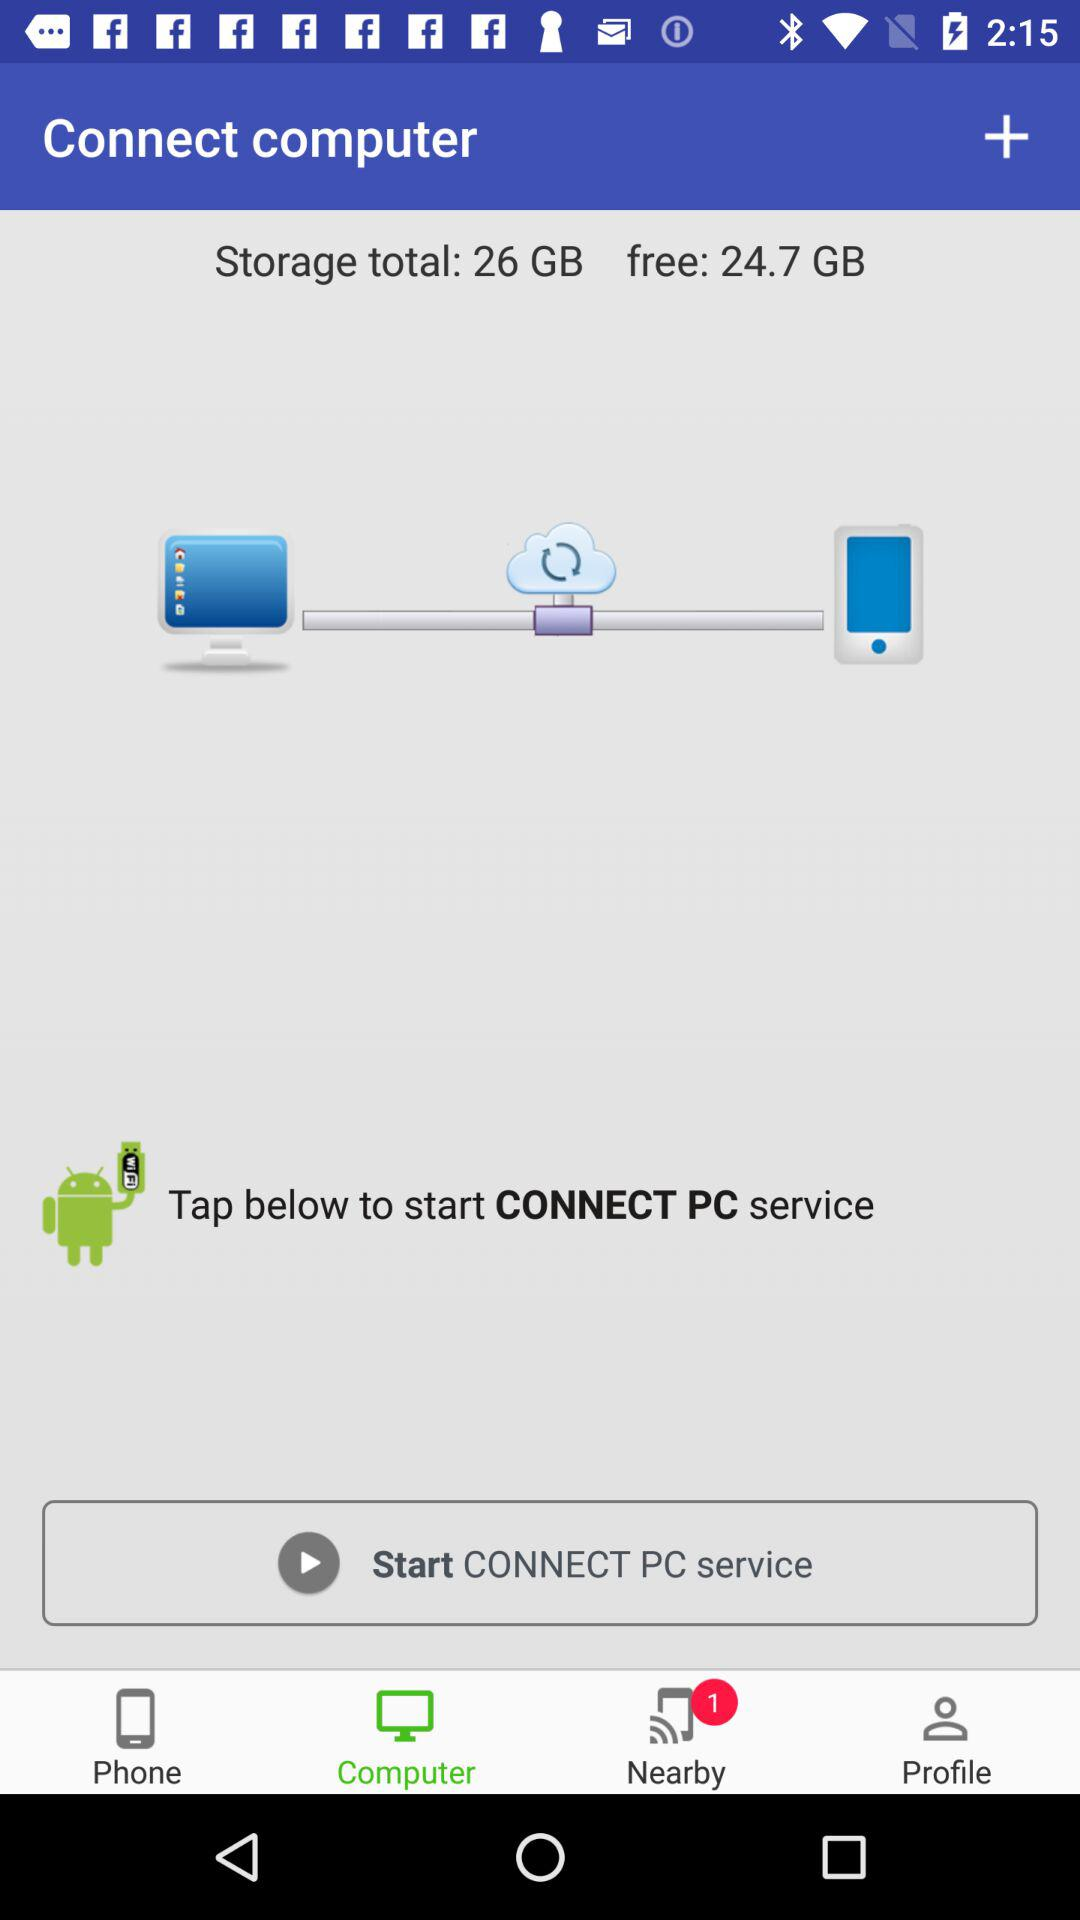How many unread notifications are there in the "Nearby" option? There is 1 unread notification. 